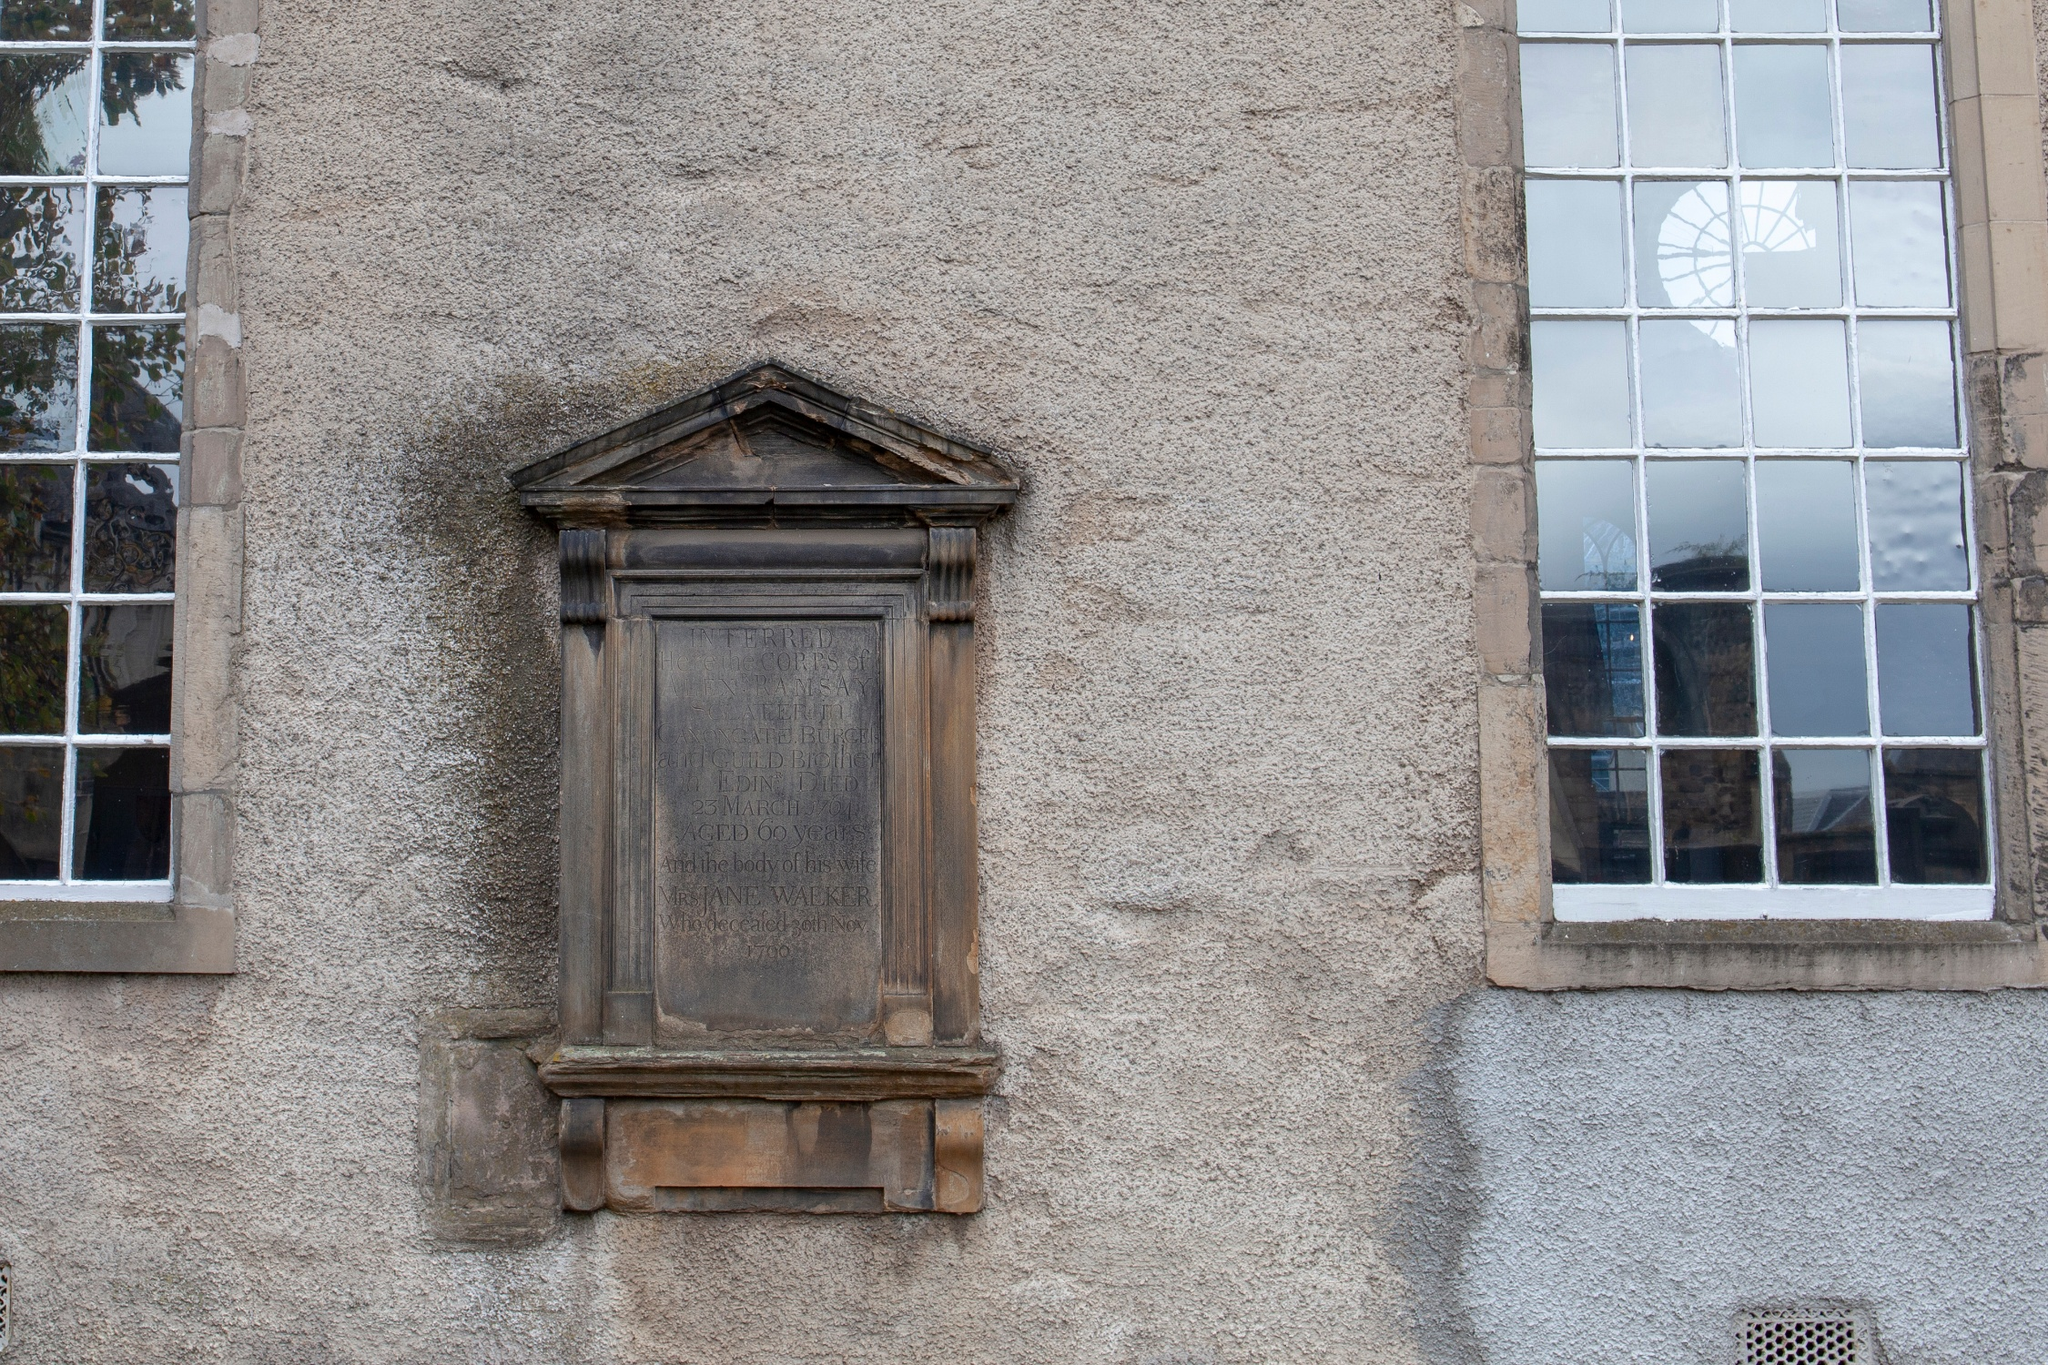Analyze the image in a comprehensive and detailed manner. The image displays an old, weathered building with a rich texture on its surface, indicative of its age and exposure to the elements. The design features two distinct window styles: left, an arched window reminiscent of traditional Roman architecture suggesting an older origin; right, a rectangular modern window, possibly a later addition or modification. The center of the image is dominated by a wooden plaque that bears an inscription, which, though eroded, hints at the building’s historical significance, potentially serving as a memorial or marker. The overall muted color palette and physical deterioration, such as the peeling paint, reinforce the structure's age and worn condition, adding a layer of historical mystery. Further investigation or context about the structure, especially details from the plaque, could provide deeper insights into its past and significance. 